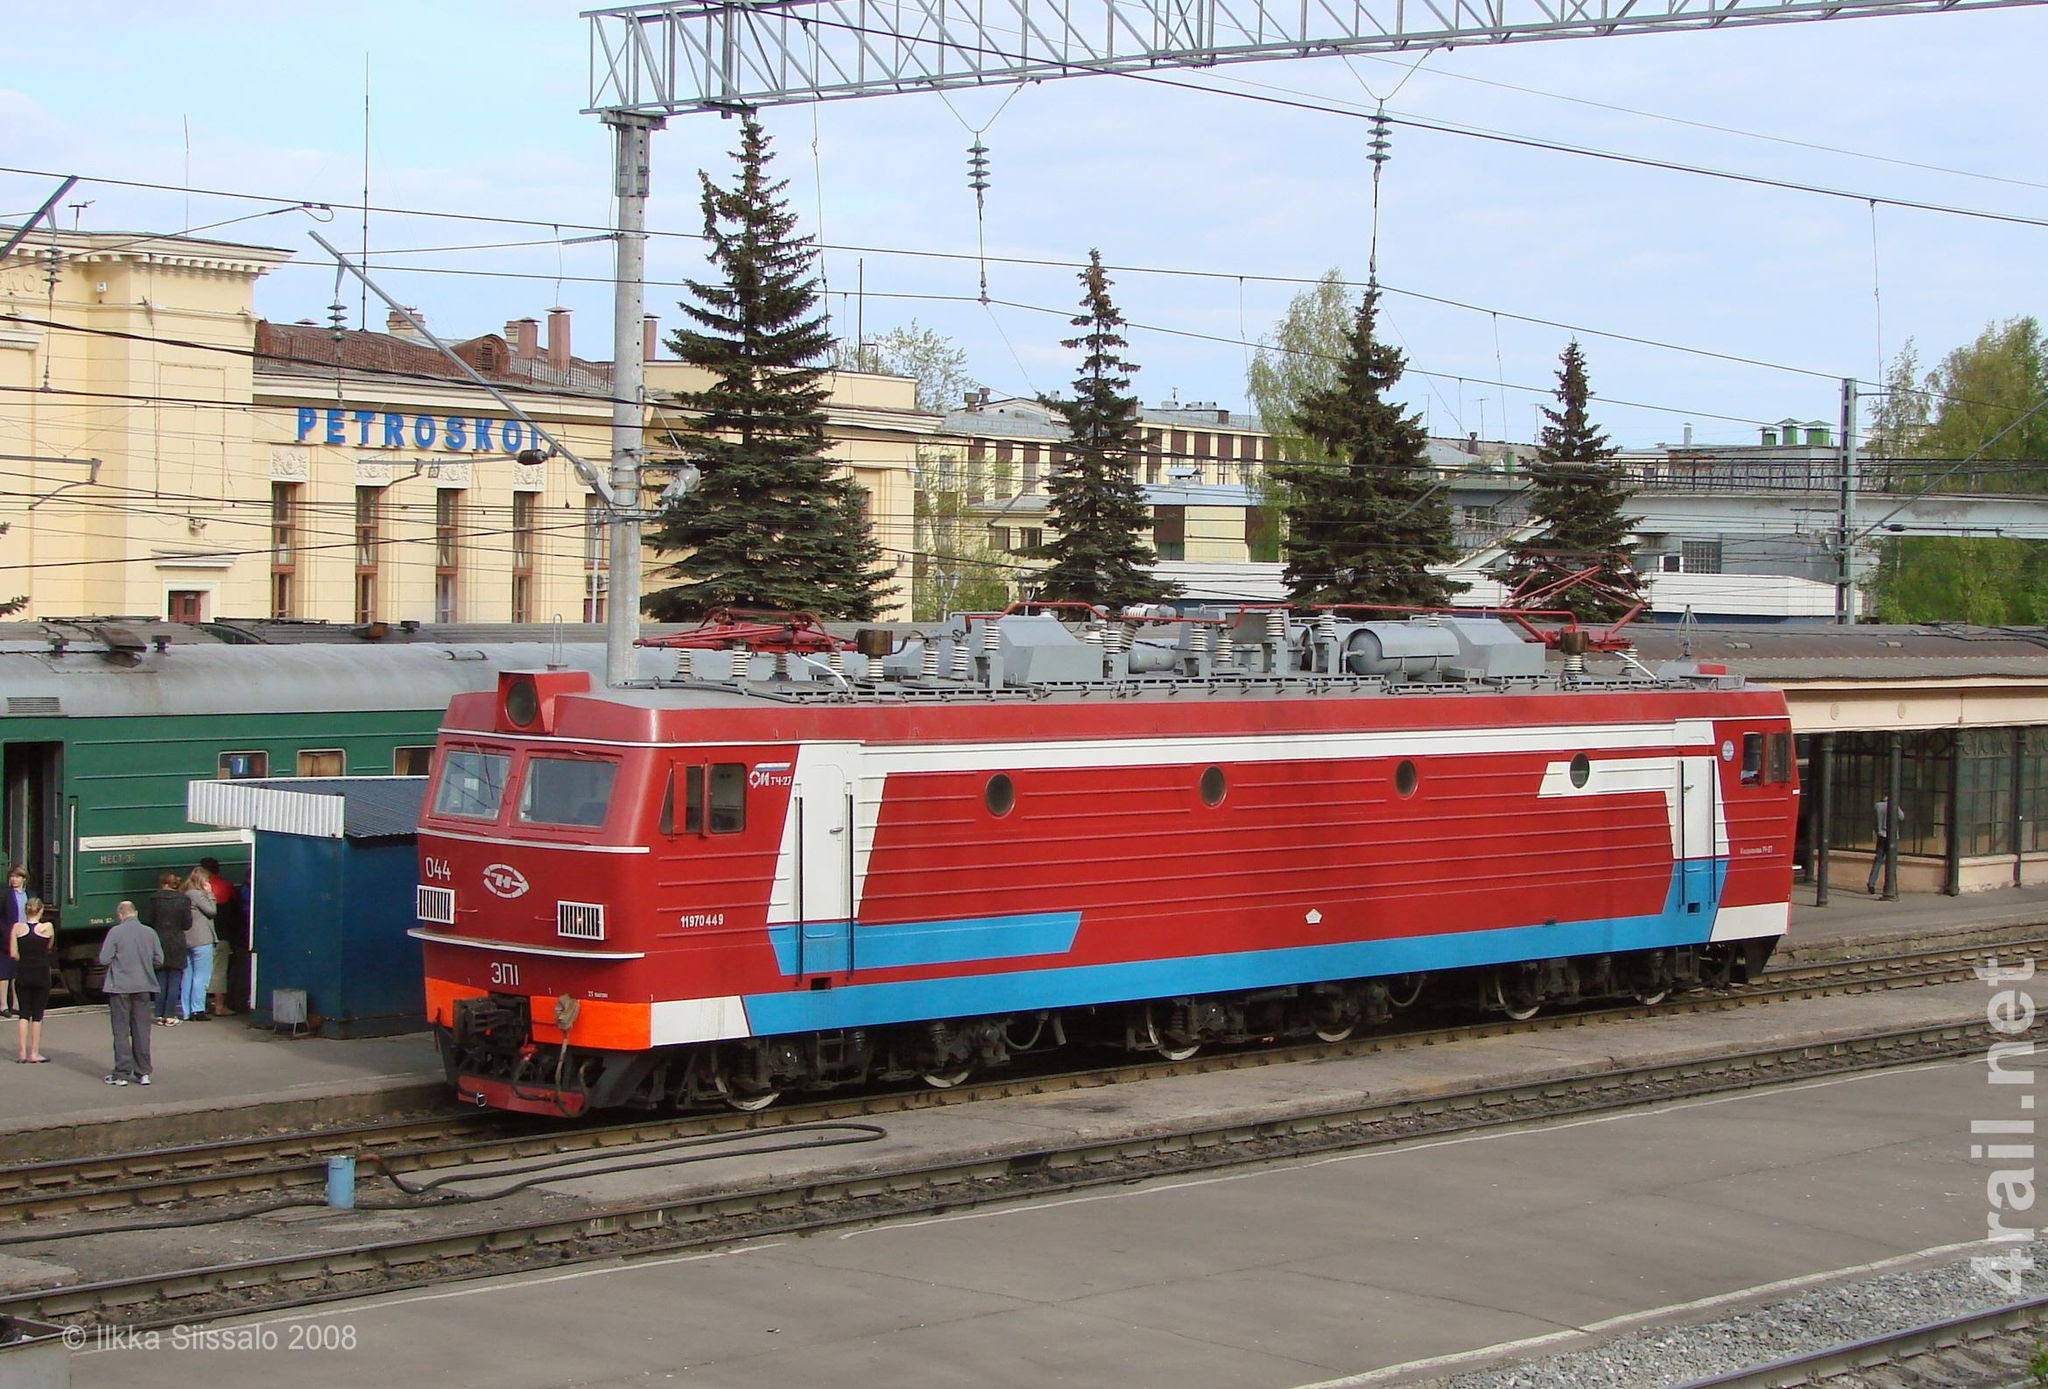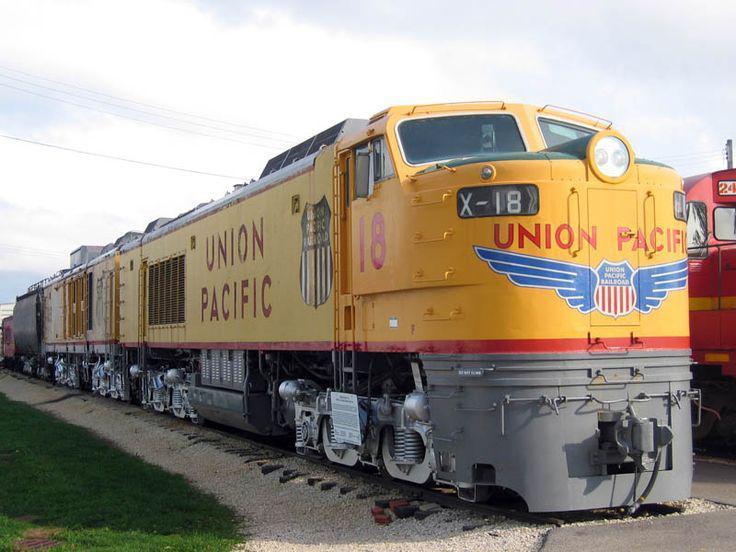The first image is the image on the left, the second image is the image on the right. Examine the images to the left and right. Is the description "There is absolutely no visible grass in any of the images." accurate? Answer yes or no. No. The first image is the image on the left, the second image is the image on the right. Examine the images to the left and right. Is the description "People wait outside the station to board a red train." accurate? Answer yes or no. Yes. 